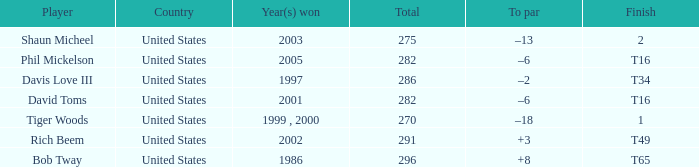In what place did Phil Mickelson finish with a total of 282? T16. 